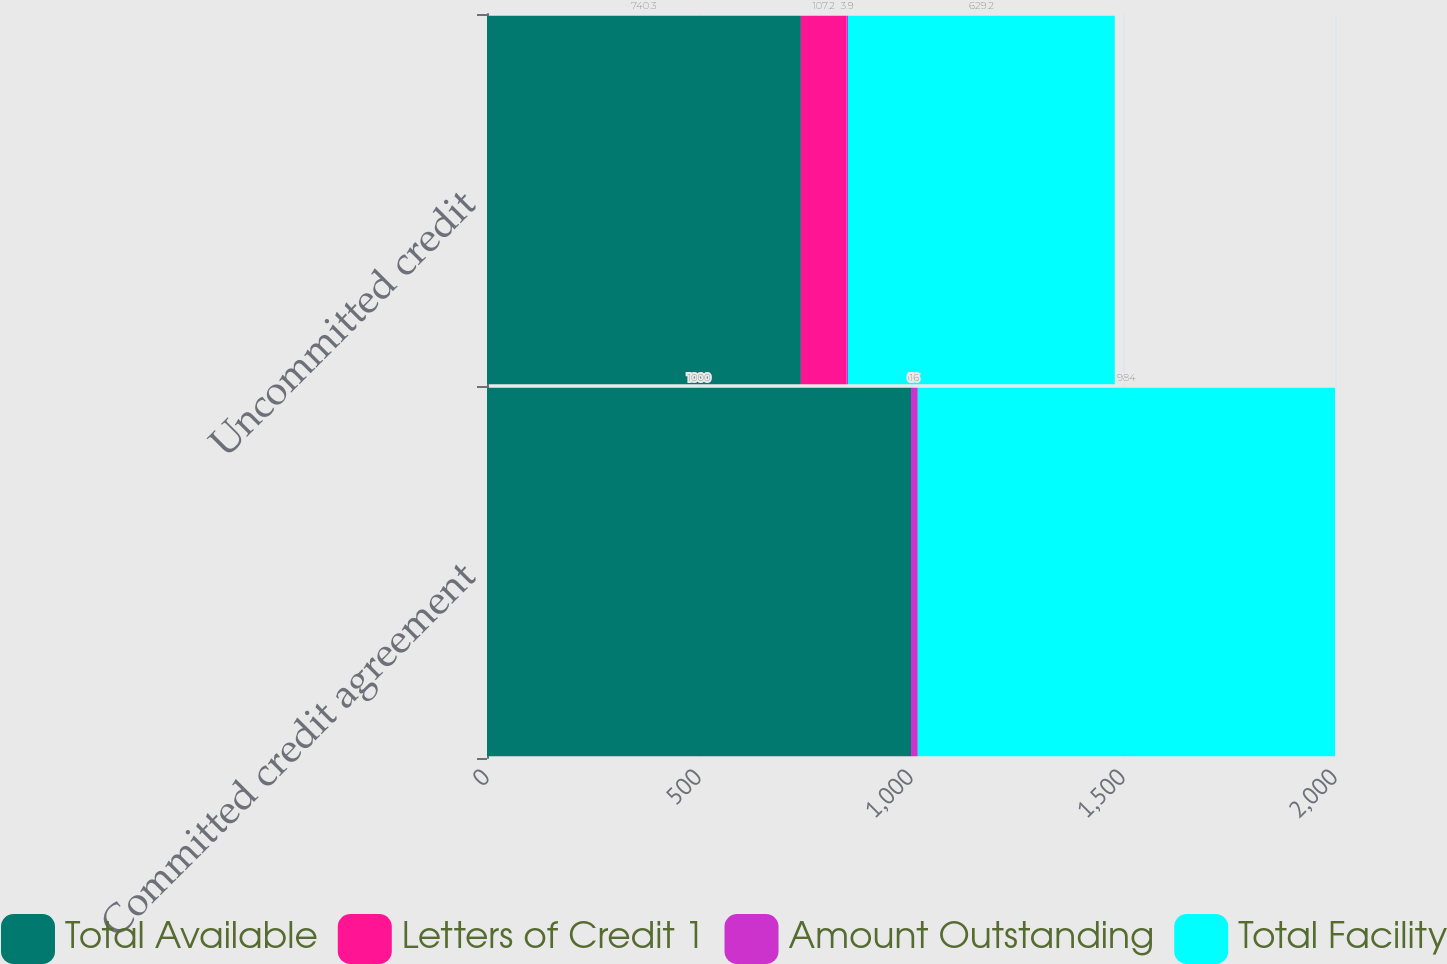Convert chart to OTSL. <chart><loc_0><loc_0><loc_500><loc_500><stacked_bar_chart><ecel><fcel>Committed credit agreement<fcel>Uncommitted credit<nl><fcel>Total Available<fcel>1000<fcel>740.3<nl><fcel>Letters of Credit 1<fcel>0<fcel>107.2<nl><fcel>Amount Outstanding<fcel>16<fcel>3.9<nl><fcel>Total Facility<fcel>984<fcel>629.2<nl></chart> 